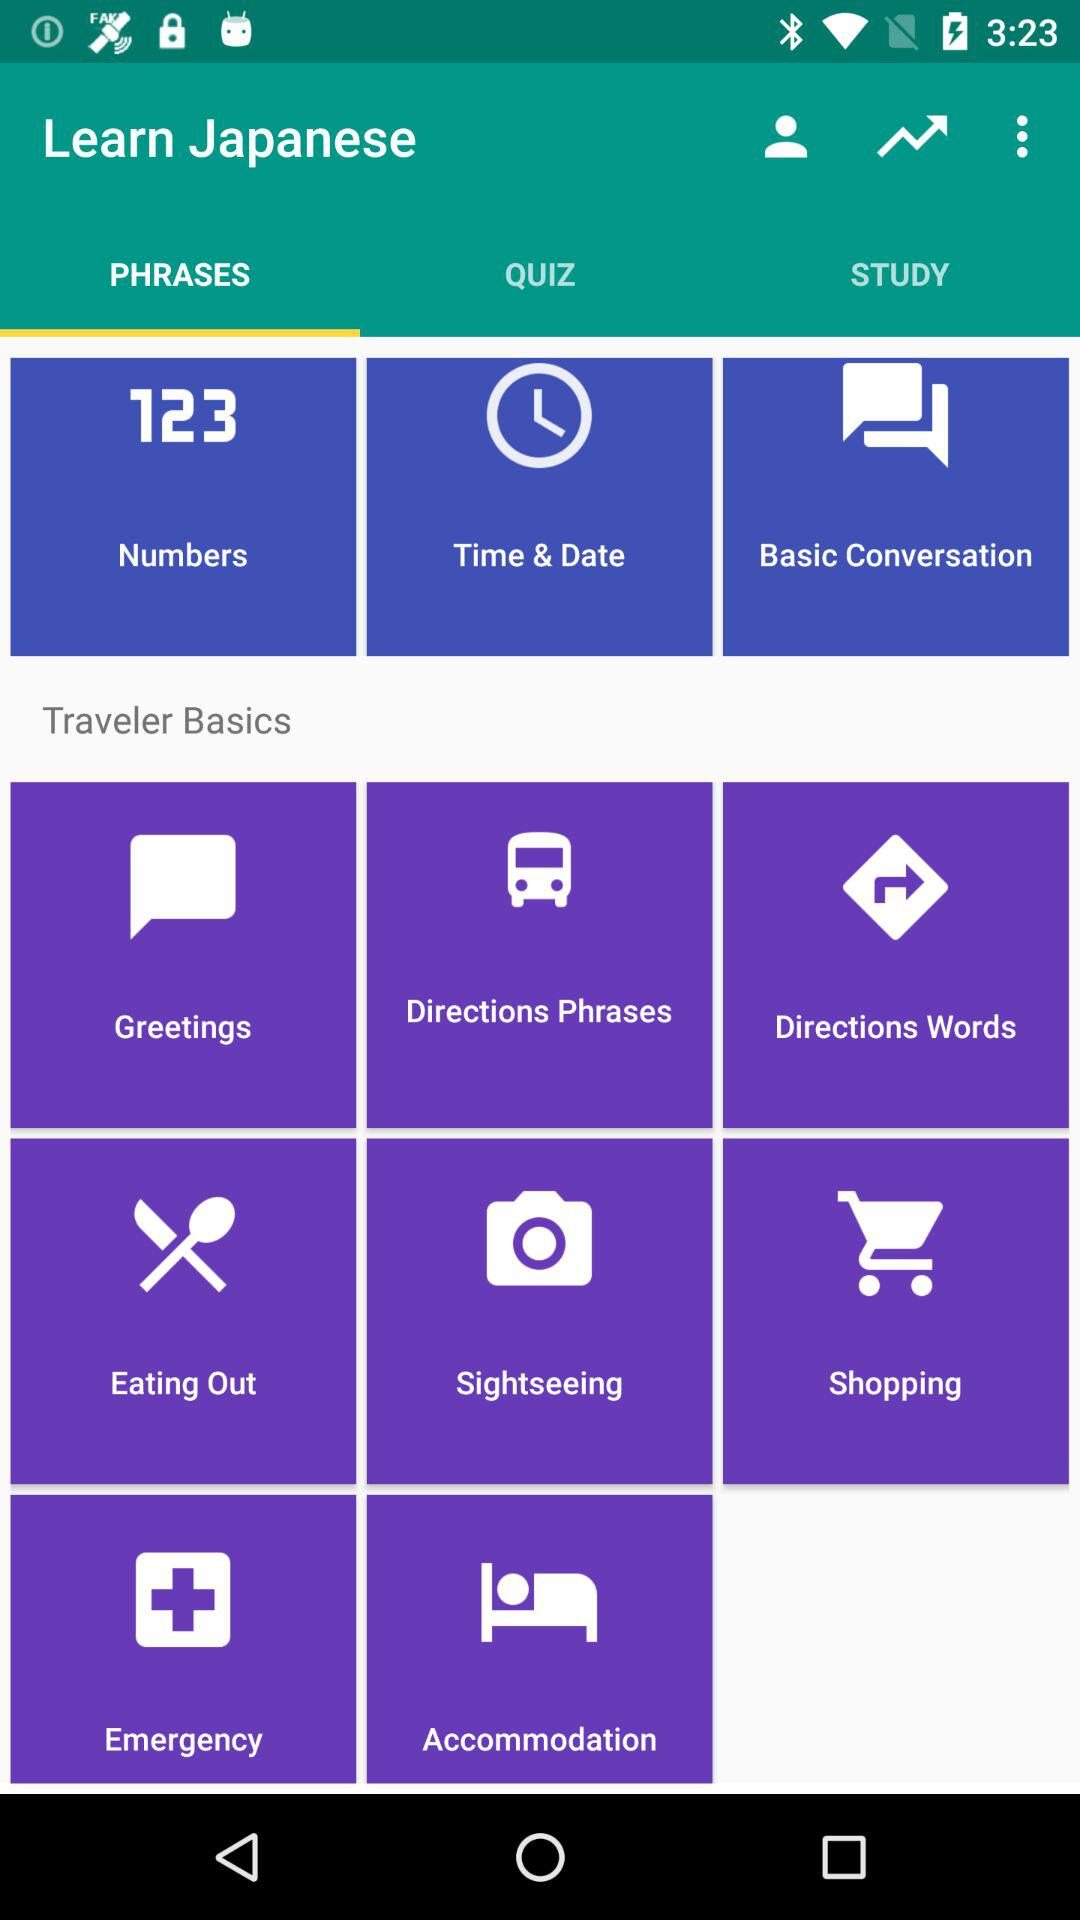Which tab is selected? The selected tab is "PHRASES". 